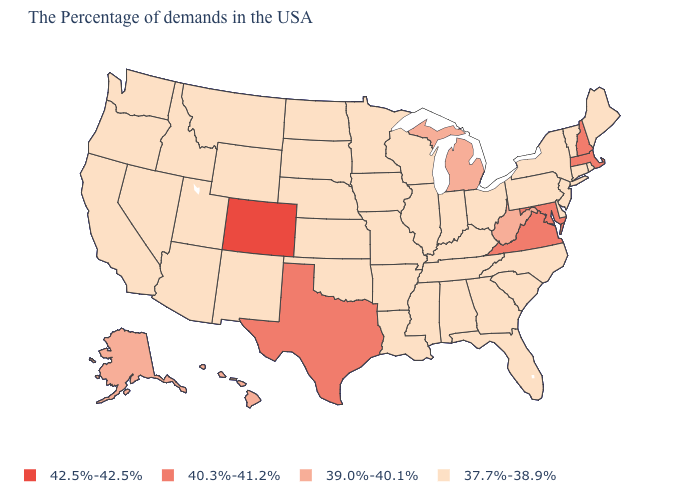What is the lowest value in states that border South Carolina?
Answer briefly. 37.7%-38.9%. Among the states that border Illinois , which have the highest value?
Quick response, please. Kentucky, Indiana, Wisconsin, Missouri, Iowa. What is the value of Utah?
Concise answer only. 37.7%-38.9%. Among the states that border Massachusetts , which have the highest value?
Short answer required. New Hampshire. Name the states that have a value in the range 37.7%-38.9%?
Keep it brief. Maine, Rhode Island, Vermont, Connecticut, New York, New Jersey, Delaware, Pennsylvania, North Carolina, South Carolina, Ohio, Florida, Georgia, Kentucky, Indiana, Alabama, Tennessee, Wisconsin, Illinois, Mississippi, Louisiana, Missouri, Arkansas, Minnesota, Iowa, Kansas, Nebraska, Oklahoma, South Dakota, North Dakota, Wyoming, New Mexico, Utah, Montana, Arizona, Idaho, Nevada, California, Washington, Oregon. Does the first symbol in the legend represent the smallest category?
Short answer required. No. Among the states that border Massachusetts , which have the lowest value?
Write a very short answer. Rhode Island, Vermont, Connecticut, New York. Does Maryland have the highest value in the South?
Short answer required. Yes. Among the states that border Arkansas , does Texas have the lowest value?
Keep it brief. No. Name the states that have a value in the range 40.3%-41.2%?
Quick response, please. Massachusetts, New Hampshire, Maryland, Virginia, Texas. What is the value of Florida?
Write a very short answer. 37.7%-38.9%. What is the value of Montana?
Write a very short answer. 37.7%-38.9%. Name the states that have a value in the range 42.5%-42.5%?
Give a very brief answer. Colorado. Which states have the lowest value in the USA?
Be succinct. Maine, Rhode Island, Vermont, Connecticut, New York, New Jersey, Delaware, Pennsylvania, North Carolina, South Carolina, Ohio, Florida, Georgia, Kentucky, Indiana, Alabama, Tennessee, Wisconsin, Illinois, Mississippi, Louisiana, Missouri, Arkansas, Minnesota, Iowa, Kansas, Nebraska, Oklahoma, South Dakota, North Dakota, Wyoming, New Mexico, Utah, Montana, Arizona, Idaho, Nevada, California, Washington, Oregon. Does Nevada have the highest value in the West?
Answer briefly. No. 